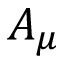Convert formula to latex. <formula><loc_0><loc_0><loc_500><loc_500>A _ { \mu }</formula> 